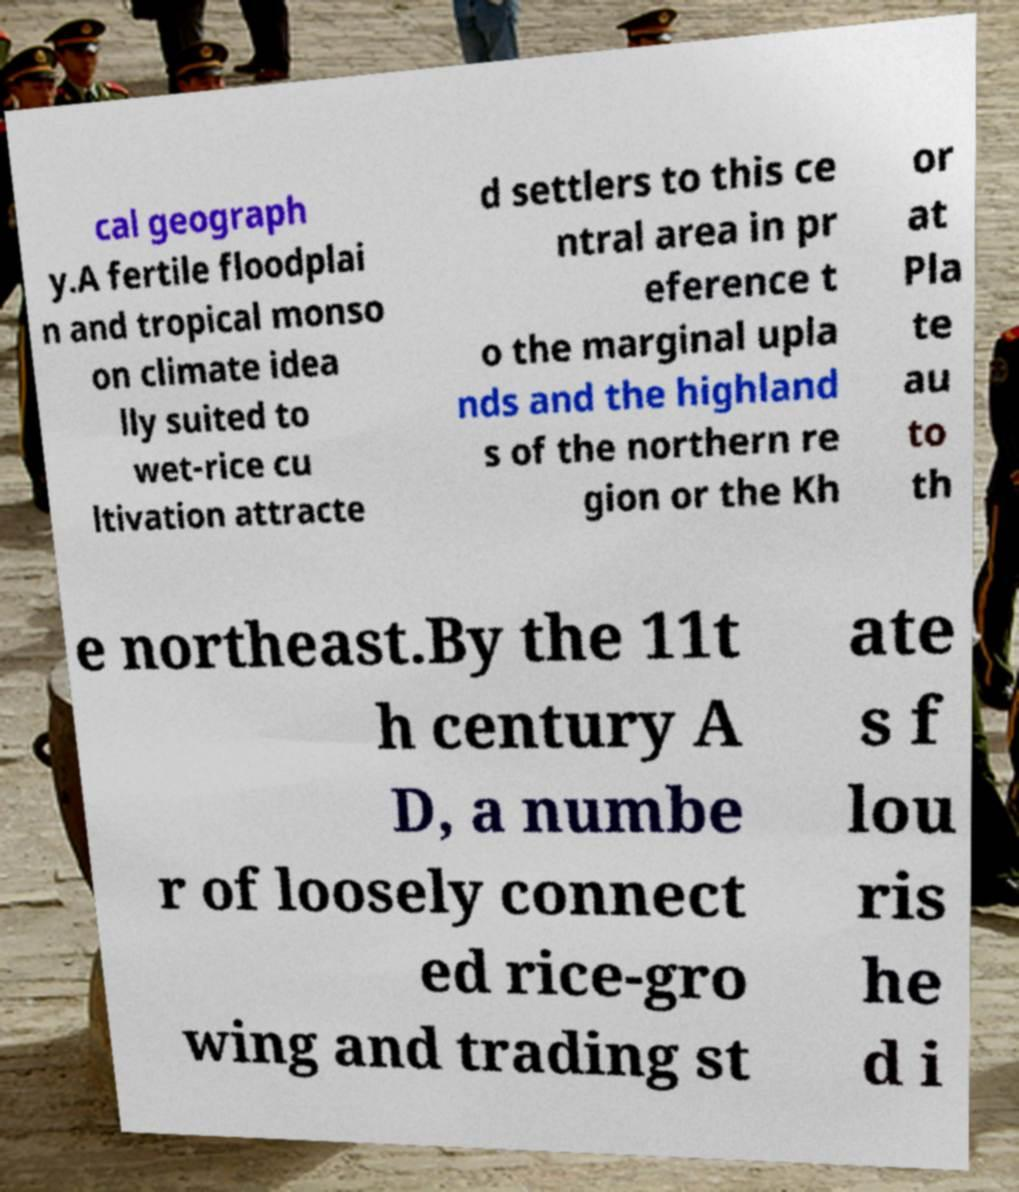Please identify and transcribe the text found in this image. cal geograph y.A fertile floodplai n and tropical monso on climate idea lly suited to wet-rice cu ltivation attracte d settlers to this ce ntral area in pr eference t o the marginal upla nds and the highland s of the northern re gion or the Kh or at Pla te au to th e northeast.By the 11t h century A D, a numbe r of loosely connect ed rice-gro wing and trading st ate s f lou ris he d i 